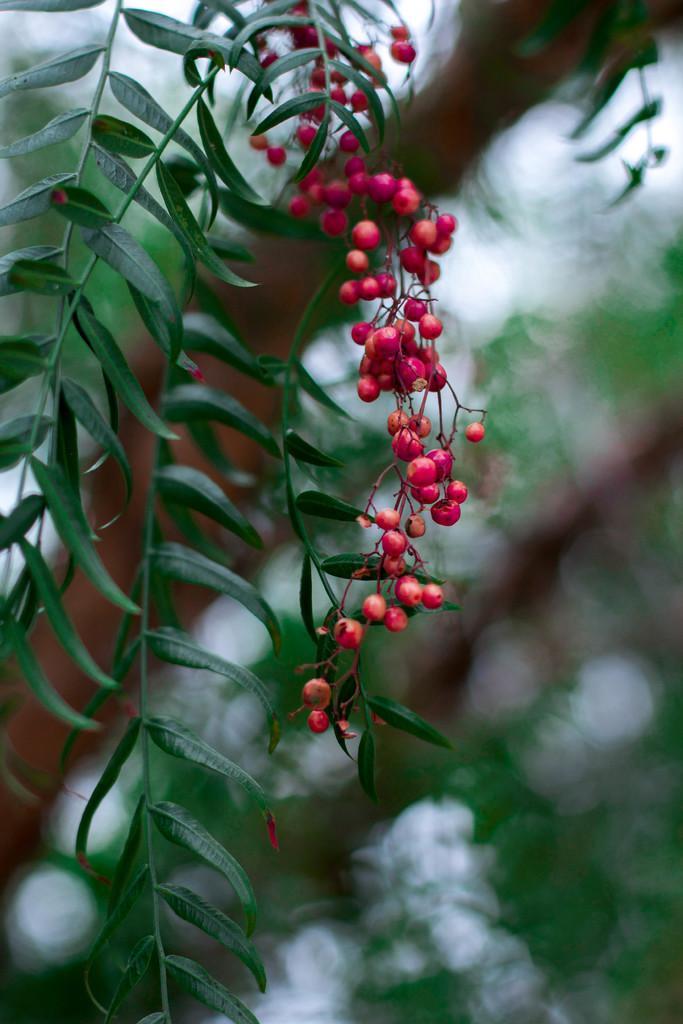Could you give a brief overview of what you see in this image? In this image I can see few fruits in red color. In the background I can see few trees in green color and the sky is in white color. 